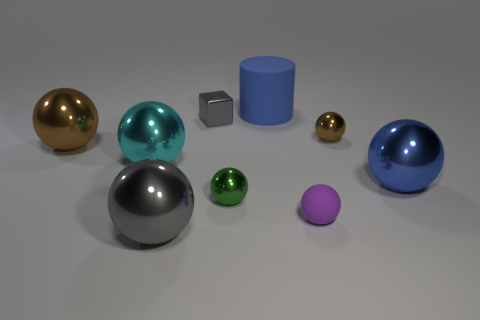What is the material of the sphere that is the same color as the rubber cylinder?
Offer a very short reply. Metal. The small thing that is behind the cyan metal object and to the left of the tiny purple object is made of what material?
Ensure brevity in your answer.  Metal. How many purple things are the same size as the shiny cube?
Your answer should be compact. 1. What is the color of the small object that is behind the brown object that is right of the large brown ball?
Provide a short and direct response. Gray. Are there any big blue metal balls?
Your response must be concise. Yes. Is the shape of the small green shiny object the same as the big cyan metallic thing?
Provide a succinct answer. Yes. There is a object that is the same color as the small metal block; what is its size?
Keep it short and to the point. Large. How many cyan shiny things are in front of the tiny shiny object in front of the large cyan metal object?
Keep it short and to the point. 0. How many metallic balls are both in front of the large cyan metal object and left of the large gray metal object?
Ensure brevity in your answer.  0. How many things are either small blue matte cubes or gray metal things behind the blue sphere?
Provide a succinct answer. 1. 